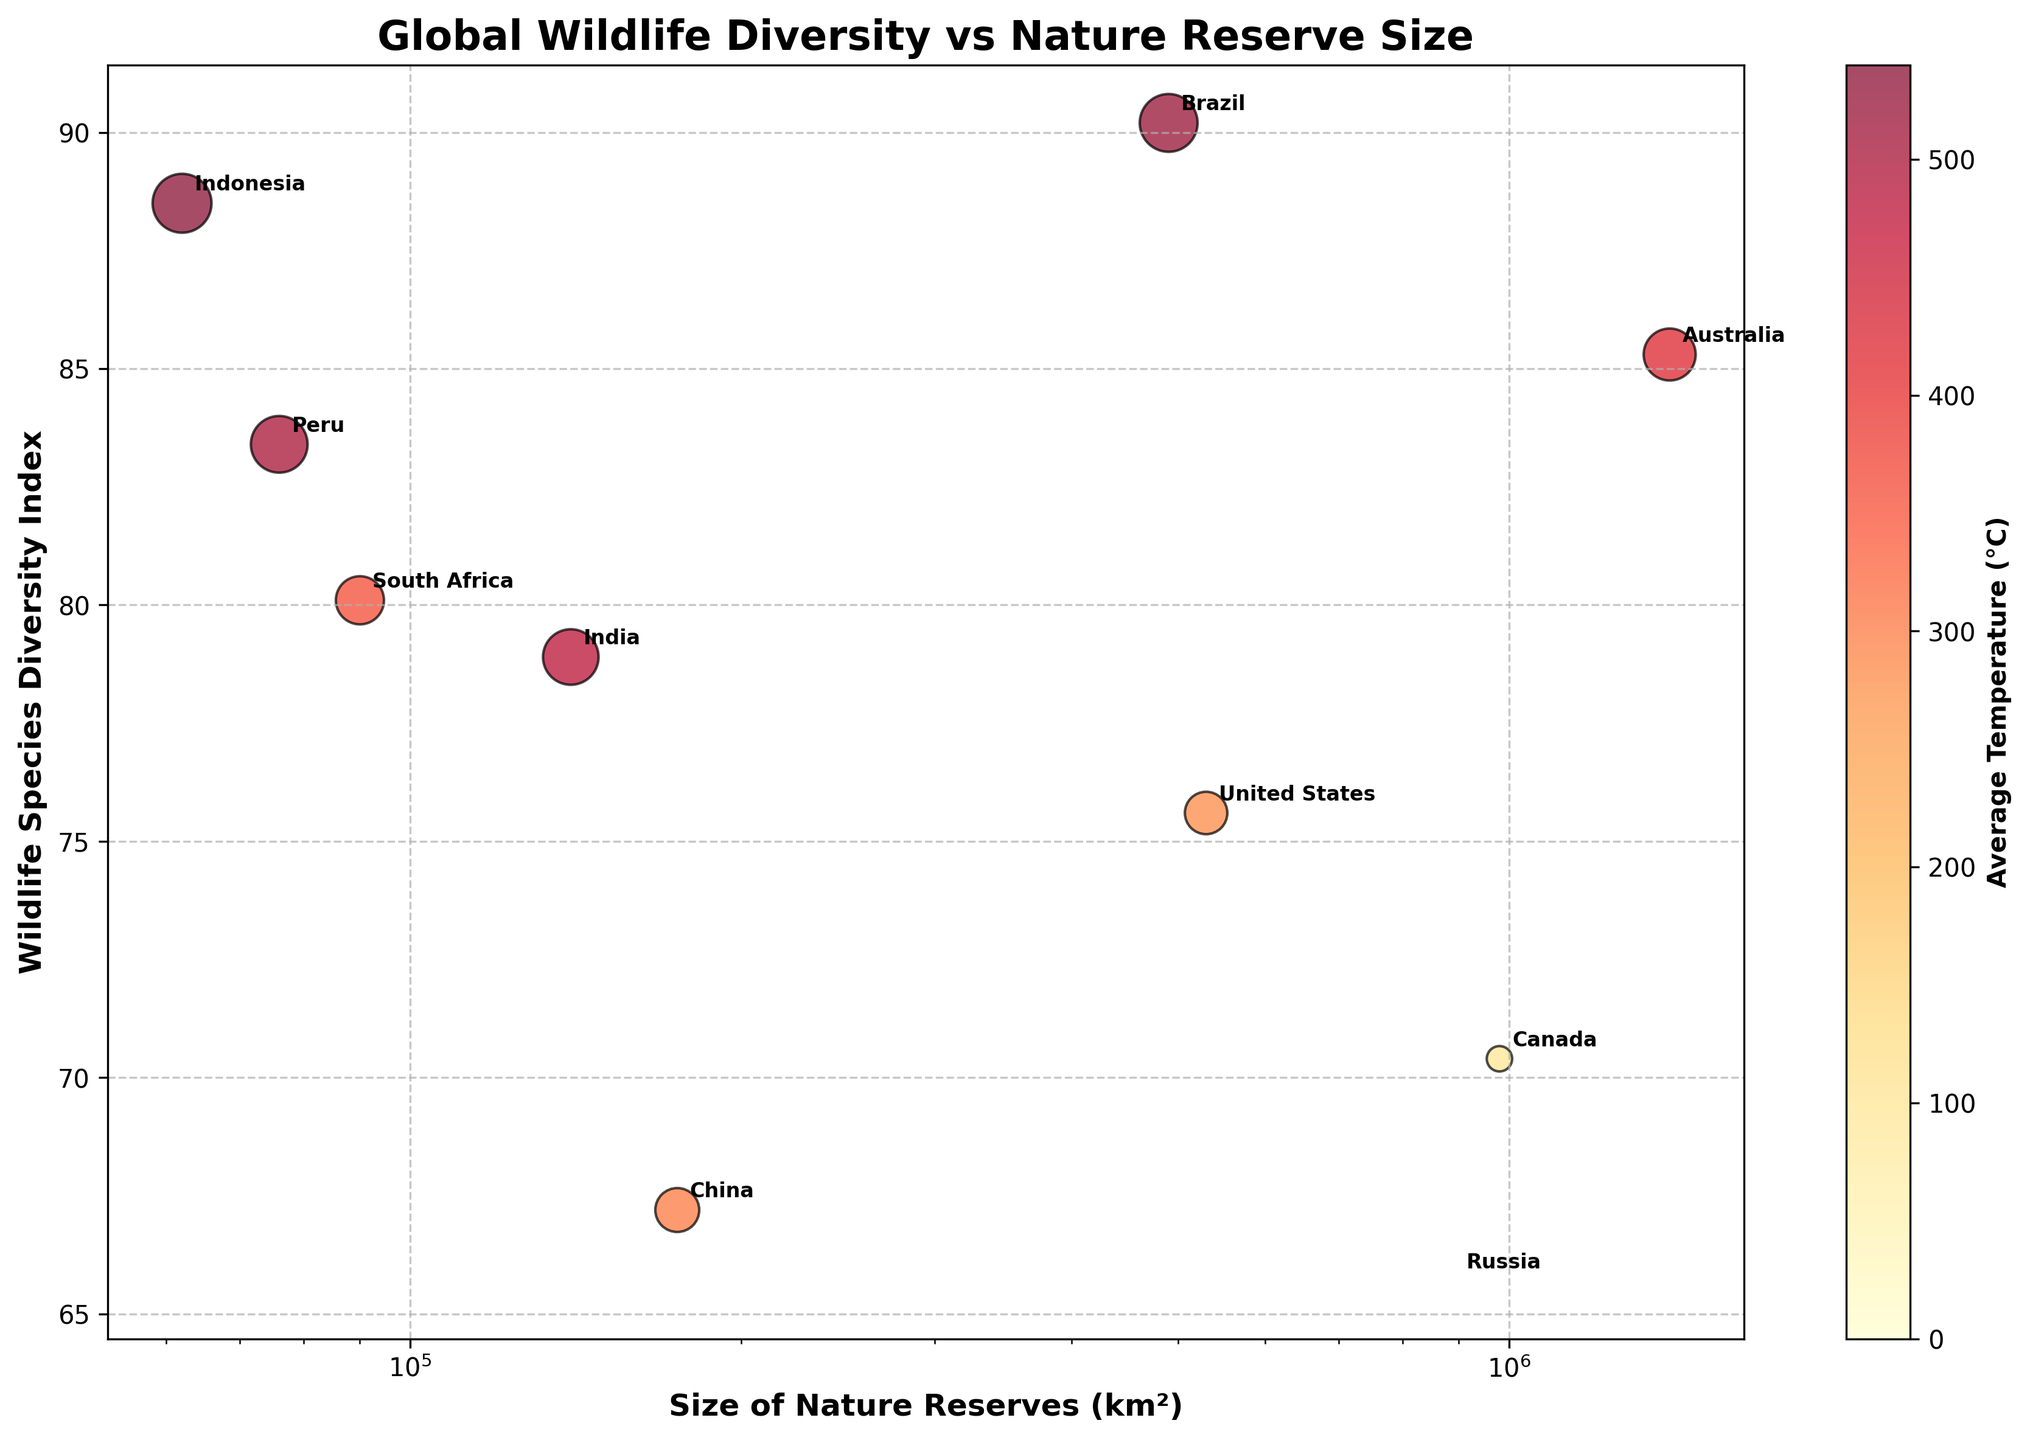What is the title of the figure? The title of the figure is typically displayed at the top center. In this case, it reads 'Global Wildlife Diversity vs Nature Reserve Size'.
Answer: Global Wildlife Diversity vs Nature Reserve Size Which country has the highest Wildlife Species Diversity Index? By looking at the vertical axis, which represents the Wildlife Species Diversity Index, the highest point is associated with Brazil (90.2).
Answer: Brazil What is the size of nature reserves in Canada? By locating Canada on the horizontal axis, which shows the Size of Nature Reserves (km²), you see it corresponds to roughly 980,000 km².
Answer: 980,000 km² Which country has the largest nature reserves and how does its Wildlife Species Diversity Index compare to Brazil? Australia has the largest nature reserves (1,400,000 km²). Comparing the vertical positions of Australia and Brazil, Australia has a Wildlife Species Diversity Index of 85.3, which is lower than Brazil's 90.2.
Answer: Australia has a lower index than Brazil (85.3 vs 90.2) What is the average Wildlife Species Diversity Index of the countries with a size of nature reserves greater than 500,000 km²? Only Brazil, Canada, the United States, and Russia have reserves greater than 500,000 km². Their diversity indices are 90.2, 70.4, 75.6, and 65.7, respectively. The average is calculated as (90.2 + 70.4 + 75.6 + 65.7) / 4 = 75.475.
Answer: 75.475 Which country corresponding to a size of nature reserves (km²) below 100,000 has the highest average temperature? Both South Africa and Peru have nature reserves below 100,000 km². By examining the bubble's sizes indicating temperatures, Peru has larger bubbles. Peru's average temperature is 25°C.
Answer: Peru How does the average temperature correlate with the Wildlife Species Diversity Index among the displayed countries? By observing the color gradient scale representing the average temperature, countries with higher temperatures like Indonesia and Brazil have higher diversity indices (~90). In contrast, countries with lower temperatures like Russia and Canada have lower indices (~65-70). This suggests a positive correlation.
Answer: Positive correlation Which two countries have the closest Wildlife Species Diversity Index values but different ranges in the size of their nature reserves? India (78.9) and the United States (75.6) have close Wildlife Species Diversity Index values. However, the size of their nature reserves varies significantly: India - 140,000 km², United States - 530,000 km².
Answer: India and the United States Do countries with larger nature reserves tend to have lower or higher average temperatures? Observing the size of the bubbles (which indicate average temperature) for countries with larger nature reserves (such as Australia, Canada, and Russia), these countries generally have moderate to low average temperatures (21°C, 5°C, and 0°C).
Answer: Lower What is the relationship between the size of nature reserves and the Wildlife Species Diversity Index in the case of Indonesia? Indonesia has relatively small nature reserves (62,000 km²) but has a high Wildlife Species Diversity Index of 88.5. This indicates that in Indonesia's case, small reserves do not necessarily correlate with low diversity.
Answer: Small reserves, high diversity 